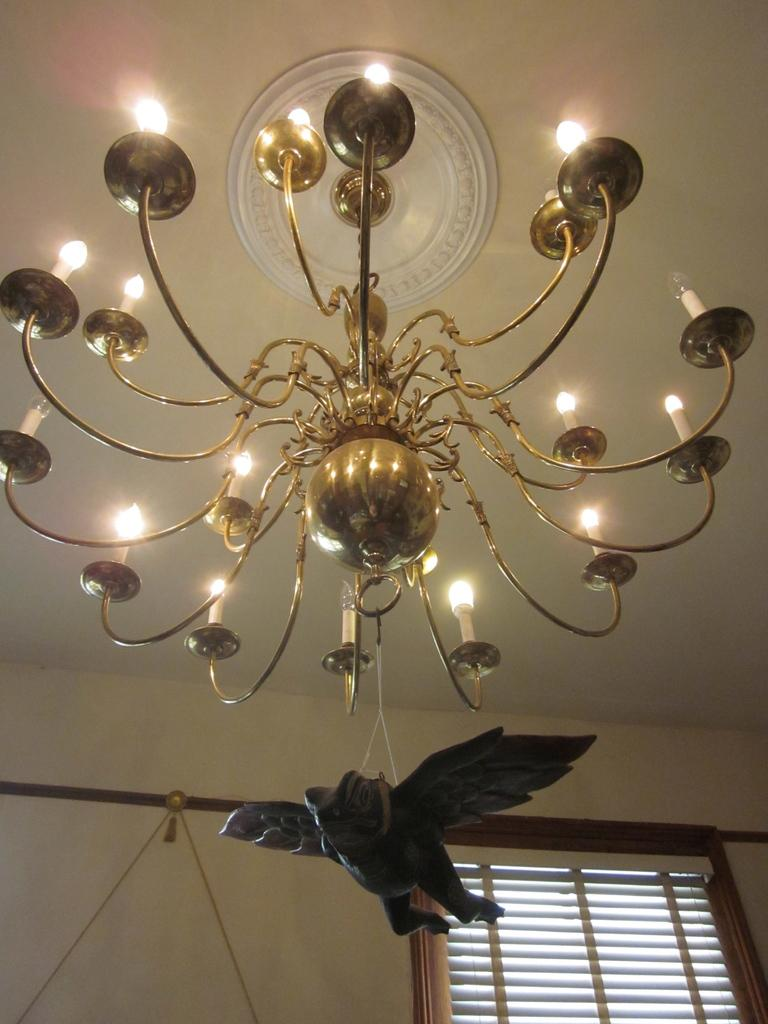What type of space is depicted in the image? The image is of a room. What feature allows natural light to enter the room? There is a window in the room. What type of lighting fixture is present in the room? There is a chandelier in the room. What is hanging from the chandelier? A sculpture is hanging from the chandelier. What type of prison can be seen in the image? There is no prison present in the image; it depicts a room with a window, chandelier, and a sculpture hanging from the chandelier. What type of scale is used to weigh the objects in the image? There is no scale present in the image, and no objects are being weighed. 